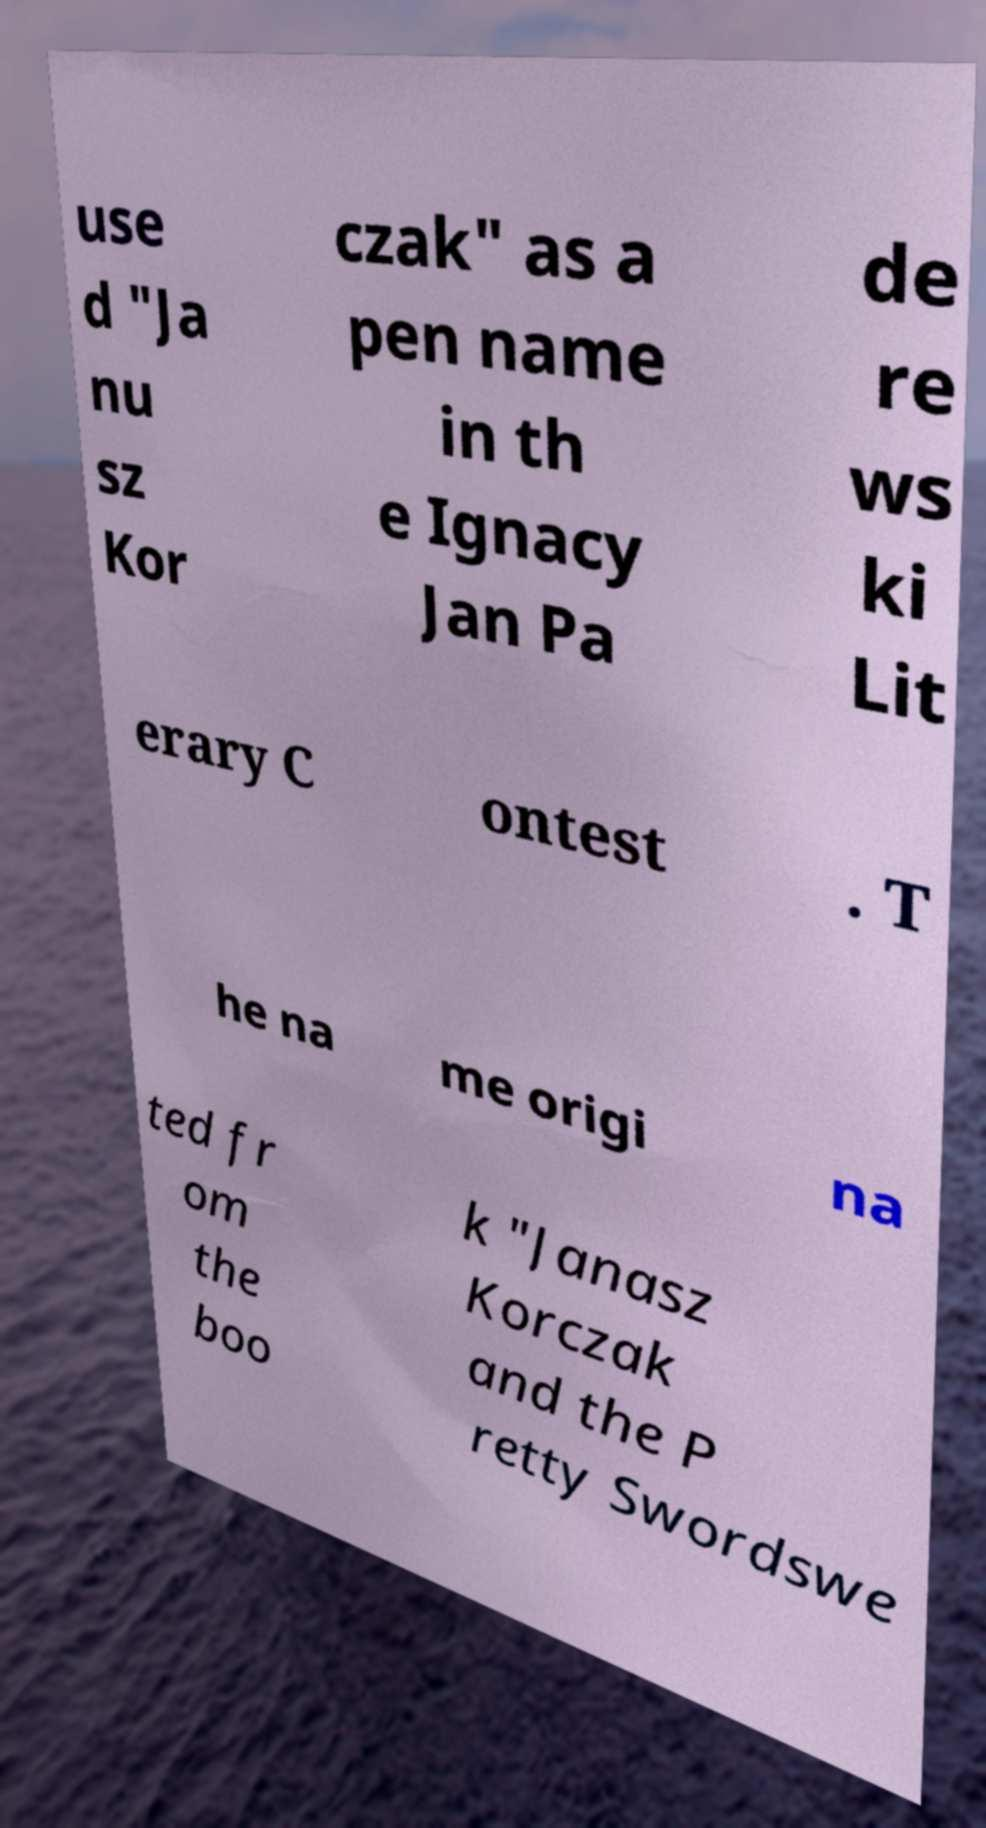Could you assist in decoding the text presented in this image and type it out clearly? use d "Ja nu sz Kor czak" as a pen name in th e Ignacy Jan Pa de re ws ki Lit erary C ontest . T he na me origi na ted fr om the boo k "Janasz Korczak and the P retty Swordswe 